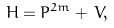<formula> <loc_0><loc_0><loc_500><loc_500>H = P ^ { 2 m } + \, V ,</formula> 